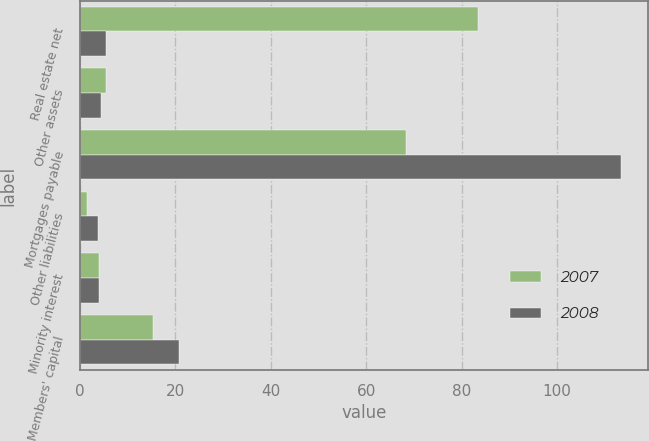<chart> <loc_0><loc_0><loc_500><loc_500><stacked_bar_chart><ecel><fcel>Real estate net<fcel>Other assets<fcel>Mortgages payable<fcel>Other liabilities<fcel>Minority interest<fcel>Members' capital<nl><fcel>2007<fcel>83.5<fcel>5.5<fcel>68.4<fcel>1.4<fcel>3.9<fcel>15.3<nl><fcel>2008<fcel>5.5<fcel>4.5<fcel>113.4<fcel>3.8<fcel>3.9<fcel>20.8<nl></chart> 